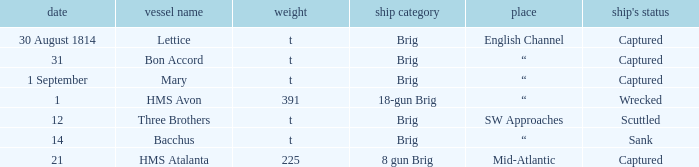With 14 under the date, what is the tonnage of the ship? T. 